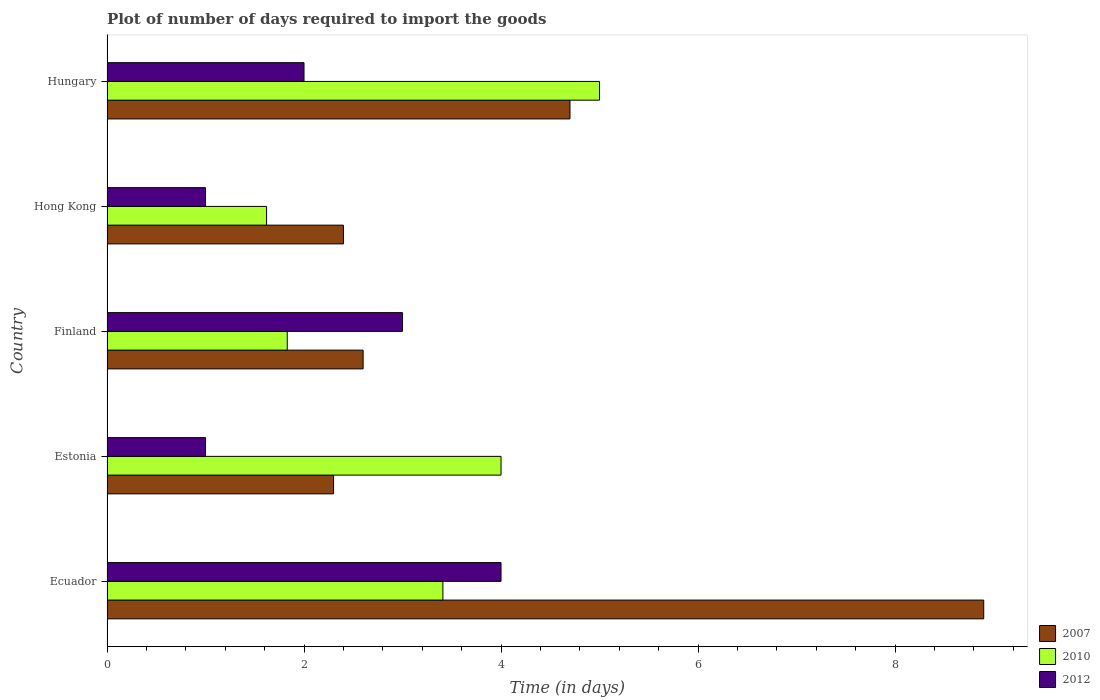How many different coloured bars are there?
Your answer should be compact. 3. Are the number of bars per tick equal to the number of legend labels?
Ensure brevity in your answer.  Yes. How many bars are there on the 2nd tick from the top?
Make the answer very short. 3. What is the label of the 4th group of bars from the top?
Your response must be concise. Estonia. In how many cases, is the number of bars for a given country not equal to the number of legend labels?
Your answer should be very brief. 0. In which country was the time required to import goods in 2012 maximum?
Offer a very short reply. Ecuador. In which country was the time required to import goods in 2007 minimum?
Give a very brief answer. Estonia. What is the total time required to import goods in 2007 in the graph?
Give a very brief answer. 20.9. What is the difference between the time required to import goods in 2007 in Estonia and that in Hungary?
Your answer should be very brief. -2.4. What is the difference between the time required to import goods in 2007 in Hong Kong and the time required to import goods in 2012 in Finland?
Give a very brief answer. -0.6. What is the average time required to import goods in 2012 per country?
Your response must be concise. 2.2. What is the difference between the time required to import goods in 2012 and time required to import goods in 2010 in Ecuador?
Offer a very short reply. 0.59. In how many countries, is the time required to import goods in 2012 greater than 8 days?
Your response must be concise. 0. What is the ratio of the time required to import goods in 2007 in Estonia to that in Hungary?
Make the answer very short. 0.49. What is the difference between the highest and the second highest time required to import goods in 2007?
Your answer should be compact. 4.2. What is the difference between the highest and the lowest time required to import goods in 2010?
Ensure brevity in your answer.  3.38. What does the 2nd bar from the top in Estonia represents?
Offer a very short reply. 2010. How many bars are there?
Provide a short and direct response. 15. Are all the bars in the graph horizontal?
Offer a very short reply. Yes. How many countries are there in the graph?
Provide a succinct answer. 5. Are the values on the major ticks of X-axis written in scientific E-notation?
Your answer should be compact. No. Does the graph contain any zero values?
Keep it short and to the point. No. Does the graph contain grids?
Keep it short and to the point. No. How many legend labels are there?
Provide a short and direct response. 3. How are the legend labels stacked?
Offer a terse response. Vertical. What is the title of the graph?
Offer a very short reply. Plot of number of days required to import the goods. What is the label or title of the X-axis?
Your answer should be very brief. Time (in days). What is the Time (in days) in 2010 in Ecuador?
Your response must be concise. 3.41. What is the Time (in days) of 2012 in Ecuador?
Offer a terse response. 4. What is the Time (in days) in 2007 in Estonia?
Keep it short and to the point. 2.3. What is the Time (in days) of 2010 in Estonia?
Offer a terse response. 4. What is the Time (in days) of 2012 in Estonia?
Provide a succinct answer. 1. What is the Time (in days) of 2010 in Finland?
Give a very brief answer. 1.83. What is the Time (in days) of 2007 in Hong Kong?
Keep it short and to the point. 2.4. What is the Time (in days) in 2010 in Hong Kong?
Give a very brief answer. 1.62. What is the Time (in days) in 2012 in Hong Kong?
Offer a very short reply. 1. Across all countries, what is the minimum Time (in days) in 2010?
Provide a short and direct response. 1.62. What is the total Time (in days) in 2007 in the graph?
Your answer should be compact. 20.9. What is the total Time (in days) of 2010 in the graph?
Your answer should be very brief. 15.86. What is the difference between the Time (in days) of 2007 in Ecuador and that in Estonia?
Provide a short and direct response. 6.6. What is the difference between the Time (in days) of 2010 in Ecuador and that in Estonia?
Offer a terse response. -0.59. What is the difference between the Time (in days) in 2007 in Ecuador and that in Finland?
Make the answer very short. 6.3. What is the difference between the Time (in days) in 2010 in Ecuador and that in Finland?
Your response must be concise. 1.58. What is the difference between the Time (in days) in 2007 in Ecuador and that in Hong Kong?
Keep it short and to the point. 6.5. What is the difference between the Time (in days) in 2010 in Ecuador and that in Hong Kong?
Keep it short and to the point. 1.79. What is the difference between the Time (in days) in 2010 in Ecuador and that in Hungary?
Keep it short and to the point. -1.59. What is the difference between the Time (in days) in 2012 in Ecuador and that in Hungary?
Keep it short and to the point. 2. What is the difference between the Time (in days) of 2007 in Estonia and that in Finland?
Your response must be concise. -0.3. What is the difference between the Time (in days) in 2010 in Estonia and that in Finland?
Your answer should be compact. 2.17. What is the difference between the Time (in days) of 2012 in Estonia and that in Finland?
Your response must be concise. -2. What is the difference between the Time (in days) in 2010 in Estonia and that in Hong Kong?
Offer a terse response. 2.38. What is the difference between the Time (in days) of 2012 in Estonia and that in Hong Kong?
Your response must be concise. 0. What is the difference between the Time (in days) of 2007 in Estonia and that in Hungary?
Keep it short and to the point. -2.4. What is the difference between the Time (in days) of 2010 in Finland and that in Hong Kong?
Your response must be concise. 0.21. What is the difference between the Time (in days) of 2012 in Finland and that in Hong Kong?
Give a very brief answer. 2. What is the difference between the Time (in days) of 2010 in Finland and that in Hungary?
Your answer should be very brief. -3.17. What is the difference between the Time (in days) in 2007 in Hong Kong and that in Hungary?
Your answer should be very brief. -2.3. What is the difference between the Time (in days) in 2010 in Hong Kong and that in Hungary?
Offer a very short reply. -3.38. What is the difference between the Time (in days) in 2007 in Ecuador and the Time (in days) in 2010 in Estonia?
Offer a terse response. 4.9. What is the difference between the Time (in days) in 2010 in Ecuador and the Time (in days) in 2012 in Estonia?
Your answer should be very brief. 2.41. What is the difference between the Time (in days) of 2007 in Ecuador and the Time (in days) of 2010 in Finland?
Your answer should be very brief. 7.07. What is the difference between the Time (in days) in 2010 in Ecuador and the Time (in days) in 2012 in Finland?
Offer a terse response. 0.41. What is the difference between the Time (in days) in 2007 in Ecuador and the Time (in days) in 2010 in Hong Kong?
Provide a succinct answer. 7.28. What is the difference between the Time (in days) in 2010 in Ecuador and the Time (in days) in 2012 in Hong Kong?
Offer a terse response. 2.41. What is the difference between the Time (in days) in 2007 in Ecuador and the Time (in days) in 2012 in Hungary?
Your answer should be very brief. 6.9. What is the difference between the Time (in days) in 2010 in Ecuador and the Time (in days) in 2012 in Hungary?
Your answer should be compact. 1.41. What is the difference between the Time (in days) in 2007 in Estonia and the Time (in days) in 2010 in Finland?
Keep it short and to the point. 0.47. What is the difference between the Time (in days) of 2010 in Estonia and the Time (in days) of 2012 in Finland?
Your answer should be very brief. 1. What is the difference between the Time (in days) in 2007 in Estonia and the Time (in days) in 2010 in Hong Kong?
Keep it short and to the point. 0.68. What is the difference between the Time (in days) of 2010 in Estonia and the Time (in days) of 2012 in Hong Kong?
Keep it short and to the point. 3. What is the difference between the Time (in days) in 2007 in Estonia and the Time (in days) in 2012 in Hungary?
Ensure brevity in your answer.  0.3. What is the difference between the Time (in days) of 2007 in Finland and the Time (in days) of 2012 in Hong Kong?
Your answer should be very brief. 1.6. What is the difference between the Time (in days) of 2010 in Finland and the Time (in days) of 2012 in Hong Kong?
Your answer should be compact. 0.83. What is the difference between the Time (in days) of 2007 in Finland and the Time (in days) of 2010 in Hungary?
Your answer should be very brief. -2.4. What is the difference between the Time (in days) in 2010 in Finland and the Time (in days) in 2012 in Hungary?
Make the answer very short. -0.17. What is the difference between the Time (in days) in 2010 in Hong Kong and the Time (in days) in 2012 in Hungary?
Give a very brief answer. -0.38. What is the average Time (in days) of 2007 per country?
Make the answer very short. 4.18. What is the average Time (in days) of 2010 per country?
Provide a succinct answer. 3.17. What is the difference between the Time (in days) of 2007 and Time (in days) of 2010 in Ecuador?
Offer a terse response. 5.49. What is the difference between the Time (in days) of 2010 and Time (in days) of 2012 in Ecuador?
Your answer should be very brief. -0.59. What is the difference between the Time (in days) of 2007 and Time (in days) of 2010 in Estonia?
Make the answer very short. -1.7. What is the difference between the Time (in days) in 2010 and Time (in days) in 2012 in Estonia?
Ensure brevity in your answer.  3. What is the difference between the Time (in days) in 2007 and Time (in days) in 2010 in Finland?
Ensure brevity in your answer.  0.77. What is the difference between the Time (in days) in 2007 and Time (in days) in 2012 in Finland?
Provide a succinct answer. -0.4. What is the difference between the Time (in days) in 2010 and Time (in days) in 2012 in Finland?
Offer a terse response. -1.17. What is the difference between the Time (in days) in 2007 and Time (in days) in 2010 in Hong Kong?
Offer a very short reply. 0.78. What is the difference between the Time (in days) in 2007 and Time (in days) in 2012 in Hong Kong?
Offer a very short reply. 1.4. What is the difference between the Time (in days) of 2010 and Time (in days) of 2012 in Hong Kong?
Offer a very short reply. 0.62. What is the ratio of the Time (in days) in 2007 in Ecuador to that in Estonia?
Your answer should be compact. 3.87. What is the ratio of the Time (in days) in 2010 in Ecuador to that in Estonia?
Offer a very short reply. 0.85. What is the ratio of the Time (in days) of 2007 in Ecuador to that in Finland?
Give a very brief answer. 3.42. What is the ratio of the Time (in days) of 2010 in Ecuador to that in Finland?
Provide a short and direct response. 1.86. What is the ratio of the Time (in days) in 2012 in Ecuador to that in Finland?
Your answer should be compact. 1.33. What is the ratio of the Time (in days) in 2007 in Ecuador to that in Hong Kong?
Make the answer very short. 3.71. What is the ratio of the Time (in days) of 2010 in Ecuador to that in Hong Kong?
Offer a terse response. 2.1. What is the ratio of the Time (in days) in 2012 in Ecuador to that in Hong Kong?
Offer a terse response. 4. What is the ratio of the Time (in days) of 2007 in Ecuador to that in Hungary?
Your answer should be compact. 1.89. What is the ratio of the Time (in days) in 2010 in Ecuador to that in Hungary?
Give a very brief answer. 0.68. What is the ratio of the Time (in days) of 2012 in Ecuador to that in Hungary?
Offer a terse response. 2. What is the ratio of the Time (in days) of 2007 in Estonia to that in Finland?
Give a very brief answer. 0.88. What is the ratio of the Time (in days) of 2010 in Estonia to that in Finland?
Give a very brief answer. 2.19. What is the ratio of the Time (in days) of 2012 in Estonia to that in Finland?
Ensure brevity in your answer.  0.33. What is the ratio of the Time (in days) of 2010 in Estonia to that in Hong Kong?
Offer a terse response. 2.47. What is the ratio of the Time (in days) in 2012 in Estonia to that in Hong Kong?
Provide a succinct answer. 1. What is the ratio of the Time (in days) in 2007 in Estonia to that in Hungary?
Your answer should be compact. 0.49. What is the ratio of the Time (in days) in 2010 in Estonia to that in Hungary?
Give a very brief answer. 0.8. What is the ratio of the Time (in days) in 2012 in Estonia to that in Hungary?
Ensure brevity in your answer.  0.5. What is the ratio of the Time (in days) of 2010 in Finland to that in Hong Kong?
Offer a terse response. 1.13. What is the ratio of the Time (in days) in 2007 in Finland to that in Hungary?
Your answer should be compact. 0.55. What is the ratio of the Time (in days) of 2010 in Finland to that in Hungary?
Your answer should be compact. 0.37. What is the ratio of the Time (in days) in 2007 in Hong Kong to that in Hungary?
Offer a very short reply. 0.51. What is the ratio of the Time (in days) of 2010 in Hong Kong to that in Hungary?
Your answer should be compact. 0.32. What is the difference between the highest and the lowest Time (in days) in 2007?
Your answer should be very brief. 6.6. What is the difference between the highest and the lowest Time (in days) in 2010?
Provide a succinct answer. 3.38. What is the difference between the highest and the lowest Time (in days) of 2012?
Your answer should be compact. 3. 